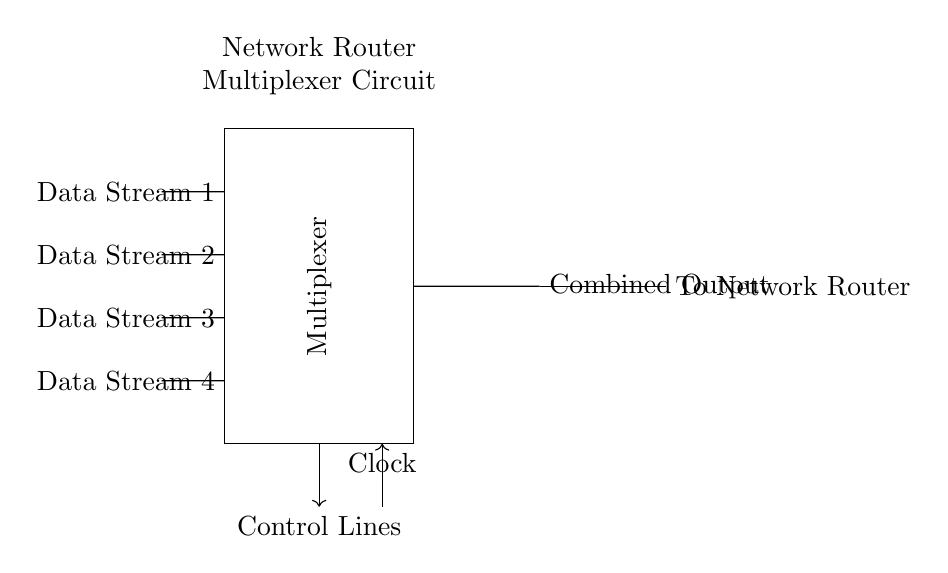What are the input data streams? The circuit diagram shows four input data streams: Data Stream 1, Data Stream 2, Data Stream 3, and Data Stream 4, represented by the lines on the left side of the diagram. Each stream is clearly labeled.
Answer: Data Stream 1, Data Stream 2, Data Stream 3, Data Stream 4 What does the rectangle in the diagram represent? The rectangle labeled as "Multiplexer" indicates that this is the component where multiple input streams are combined into one output stream. It is a central part of the circuit.
Answer: Multiplexer What is the function of the clock in this circuit? The clock provides timing signals that synchronize the operation of the multiplexer. It ensures that data is selected at the right time based on the control lines.
Answer: Synchronization How many control lines are shown in the circuit? The diagram shows one set of control lines represented by an arrow pointing downwards, indicating that control signals will be provided to manage which data stream is outputted.
Answer: One What is the output of the multiplexer? The output of the multiplexer is labeled as "Combined Output," which signifies that this is the single output stream that results from combining the input data streams based on the control signals.
Answer: Combined Output What component is used after the multiplexer? Following the multiplexer, there is a buffer indicated by the symbol that shows it will strengthen or stabilize the combined output before it is sent to the network router.
Answer: Buffer What does the label "To Network Router" indicate? This label signifies that the combined output from the buffer is directed to the network router, implying that this circuit is designed to forward data to the router for processing.
Answer: To Network Router 